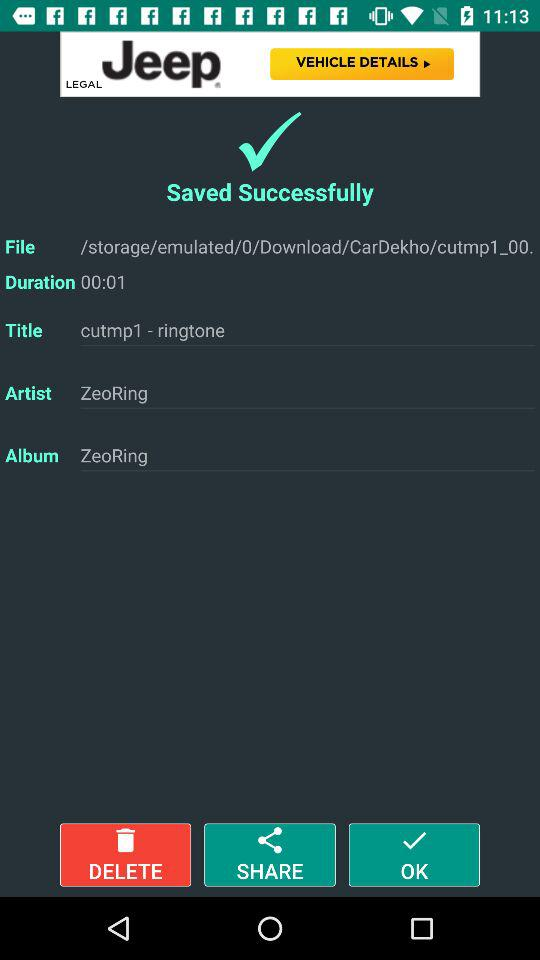What's the artist name? The artist name is "ZeoRing". 